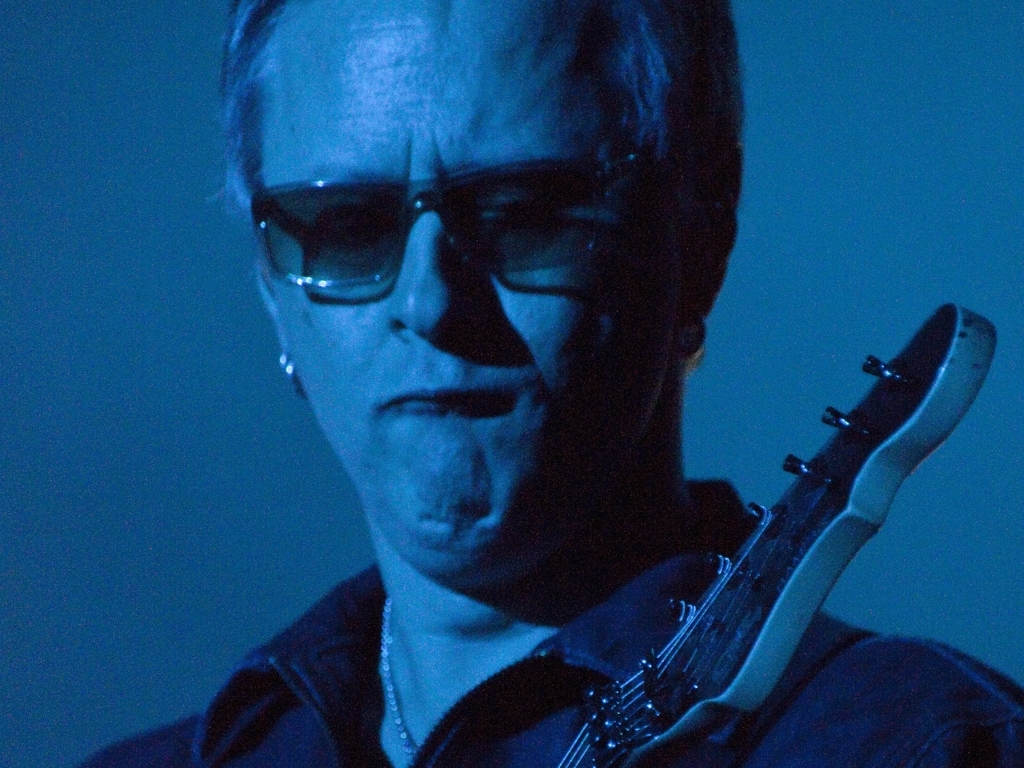The lighting in this image has created an interesting mood. Can we describe what mood it establishes and how it affects the subject? The lighting in the image, primarily a cool blue tone, creates a somber and introspective mood. It casts deep shadows on the subject's face, emphasizing a brooding or intense expression that fits with a musical or artistic performance setting. This type of light could suggest a reflective or melancholic atmosphere, possibly conveying the emotional depth of a blues musician engrossed in their craft. 